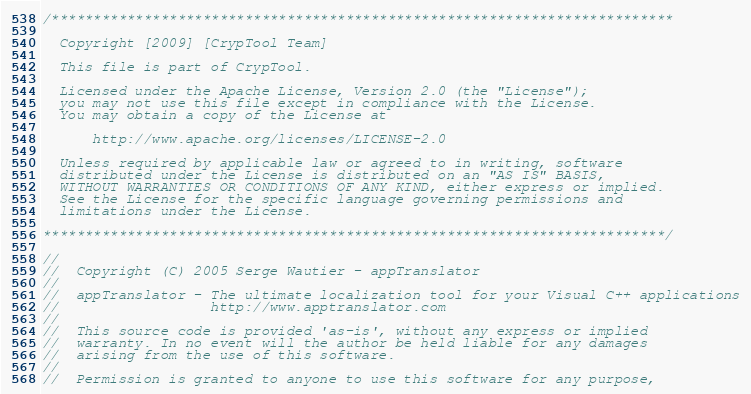<code> <loc_0><loc_0><loc_500><loc_500><_C++_>/**************************************************************************

  Copyright [2009] [CrypTool Team]

  This file is part of CrypTool.

  Licensed under the Apache License, Version 2.0 (the "License");
  you may not use this file except in compliance with the License.
  You may obtain a copy of the License at

      http://www.apache.org/licenses/LICENSE-2.0

  Unless required by applicable law or agreed to in writing, software
  distributed under the License is distributed on an "AS IS" BASIS,
  WITHOUT WARRANTIES OR CONDITIONS OF ANY KIND, either express or implied.
  See the License for the specific language governing permissions and
  limitations under the License.

**************************************************************************/

//
//  Copyright (C) 2005 Serge Wautier - appTranslator
//  
//  appTranslator - The ultimate localization tool for your Visual C++ applications
//                  http://www.apptranslator.com
//
//  This source code is provided 'as-is', without any express or implied
//  warranty. In no event will the author be held liable for any damages
//  arising from the use of this software.
//
//  Permission is granted to anyone to use this software for any purpose,</code> 